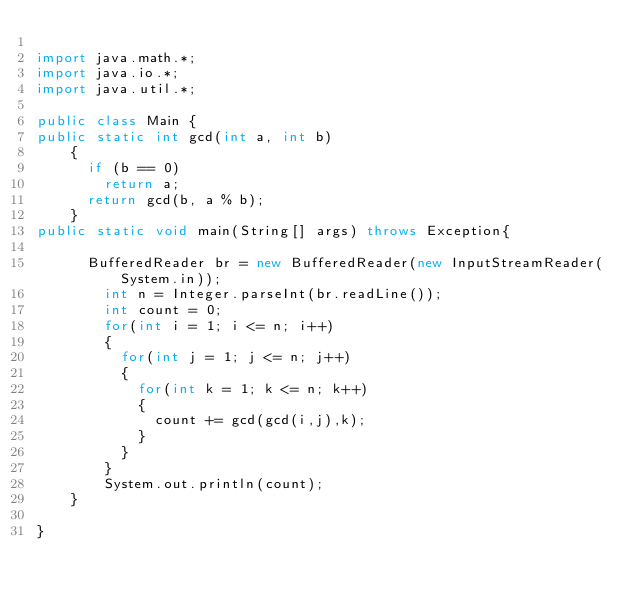<code> <loc_0><loc_0><loc_500><loc_500><_Java_>
import java.math.*;
import java.io.*;
import java.util.*;

public class Main {
public static int gcd(int a, int b) 
    { 
      if (b == 0) 
        return a; 
      return gcd(b, a % b);  
    }
public static void main(String[] args) throws Exception{

    	BufferedReader br = new BufferedReader(new InputStreamReader(System.in));
      	int n = Integer.parseInt(br.readLine());
      	int count = 0;
      	for(int i = 1; i <= n; i++)
      	{
      		for(int j = 1; j <= n; j++)
      		{
      			for(int k = 1; k <= n; k++)
      			{
      				count += gcd(gcd(i,j),k);
      			}
      		}
      	}
      	System.out.println(count);
    }

}


</code> 